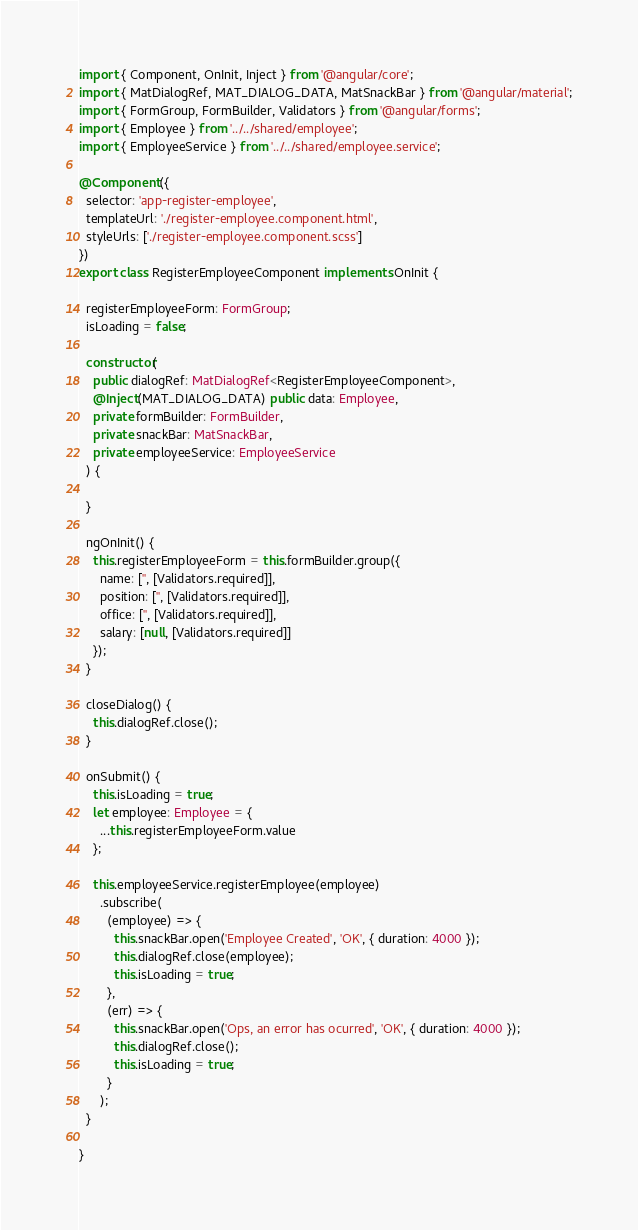<code> <loc_0><loc_0><loc_500><loc_500><_TypeScript_>import { Component, OnInit, Inject } from '@angular/core';
import { MatDialogRef, MAT_DIALOG_DATA, MatSnackBar } from '@angular/material';
import { FormGroup, FormBuilder, Validators } from '@angular/forms';
import { Employee } from '../../shared/employee';
import { EmployeeService } from '../../shared/employee.service';

@Component({
  selector: 'app-register-employee',
  templateUrl: './register-employee.component.html',
  styleUrls: ['./register-employee.component.scss']
})
export class RegisterEmployeeComponent implements OnInit {

  registerEmployeeForm: FormGroup;
  isLoading = false;

  constructor(
    public dialogRef: MatDialogRef<RegisterEmployeeComponent>,
    @Inject(MAT_DIALOG_DATA) public data: Employee,
    private formBuilder: FormBuilder,
    private snackBar: MatSnackBar,
    private employeeService: EmployeeService
  ) {

  }

  ngOnInit() {
    this.registerEmployeeForm = this.formBuilder.group({
      name: ['', [Validators.required]],
      position: ['', [Validators.required]],
      office: ['', [Validators.required]],
      salary: [null, [Validators.required]]
    });
  }

  closeDialog() {
    this.dialogRef.close();
  }

  onSubmit() {
    this.isLoading = true;
    let employee: Employee = {
      ...this.registerEmployeeForm.value
    };

    this.employeeService.registerEmployee(employee)
      .subscribe(
        (employee) => {
          this.snackBar.open('Employee Created', 'OK', { duration: 4000 });
          this.dialogRef.close(employee);
          this.isLoading = true;
        },
        (err) => {
          this.snackBar.open('Ops, an error has ocurred', 'OK', { duration: 4000 });
          this.dialogRef.close();
          this.isLoading = true;
        }
      );
  }

}
</code> 